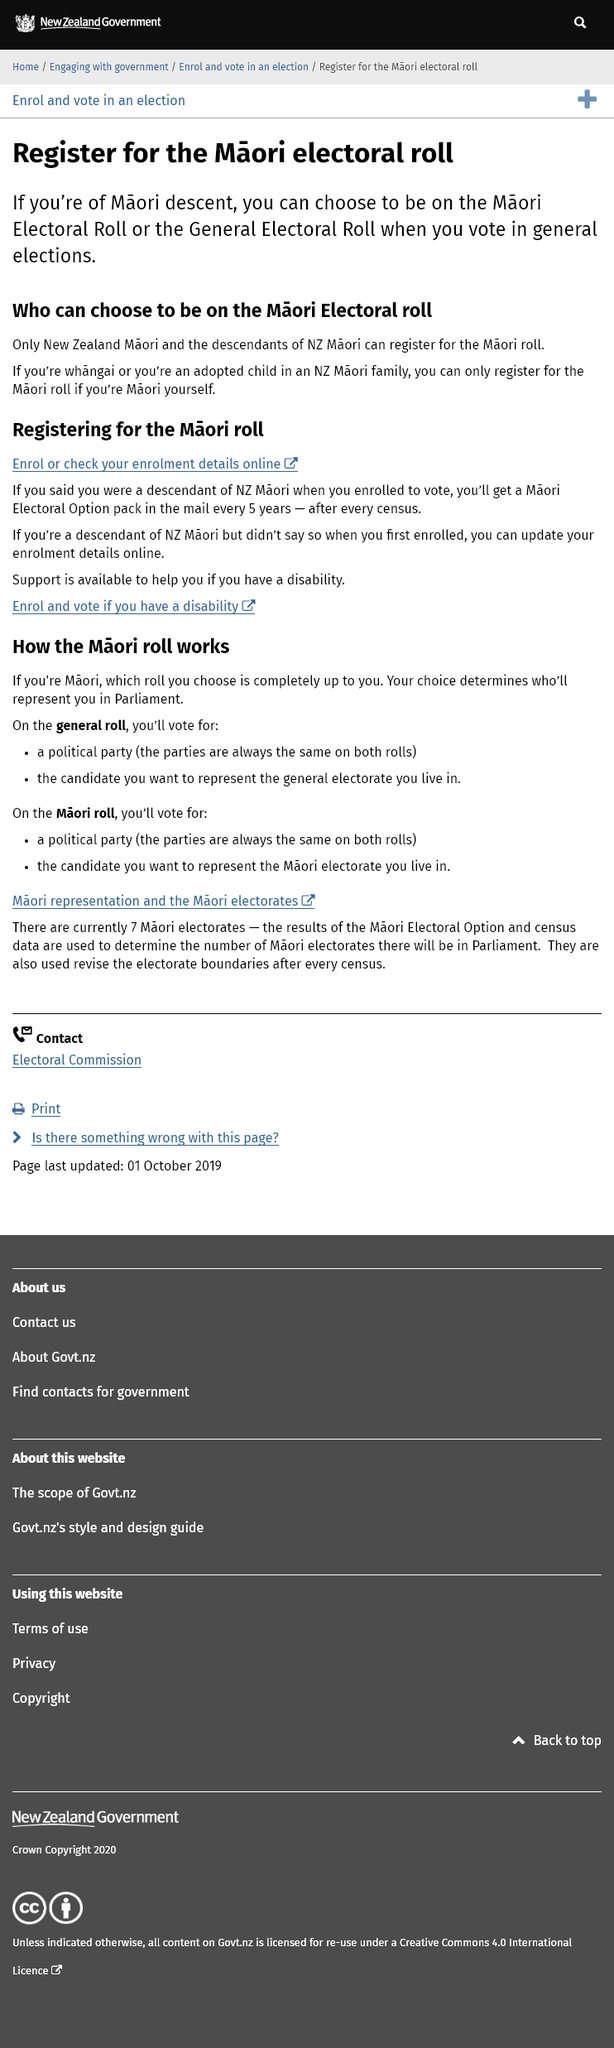Give some essential details in this illustration. To vote in general elections as a Maori descent, you have the option to register on either the Maori Electoral Roll or the General Electoral Roll. Only New Zealand Maori and their descendants are eligible to register for the Maori electoral roll. An adopted child, who is a member of a Maori family and has been raised as one, can only register for the Maori electoral roll if they themselves are of Maori descent. 